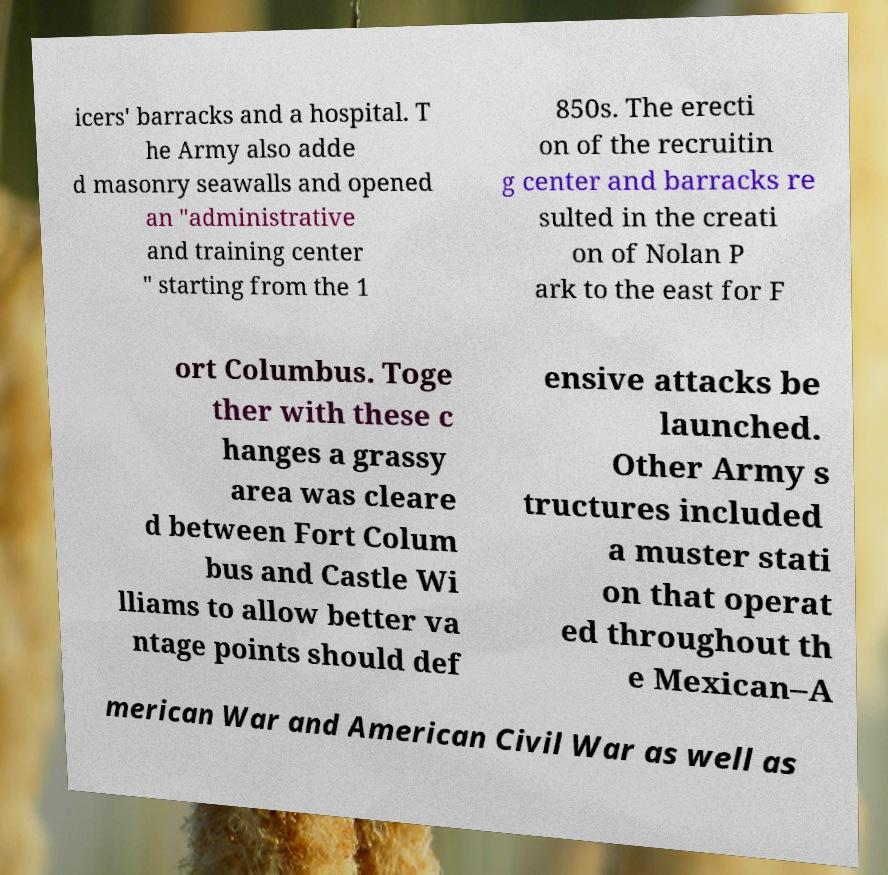Can you accurately transcribe the text from the provided image for me? icers' barracks and a hospital. T he Army also adde d masonry seawalls and opened an "administrative and training center " starting from the 1 850s. The erecti on of the recruitin g center and barracks re sulted in the creati on of Nolan P ark to the east for F ort Columbus. Toge ther with these c hanges a grassy area was cleare d between Fort Colum bus and Castle Wi lliams to allow better va ntage points should def ensive attacks be launched. Other Army s tructures included a muster stati on that operat ed throughout th e Mexican–A merican War and American Civil War as well as 